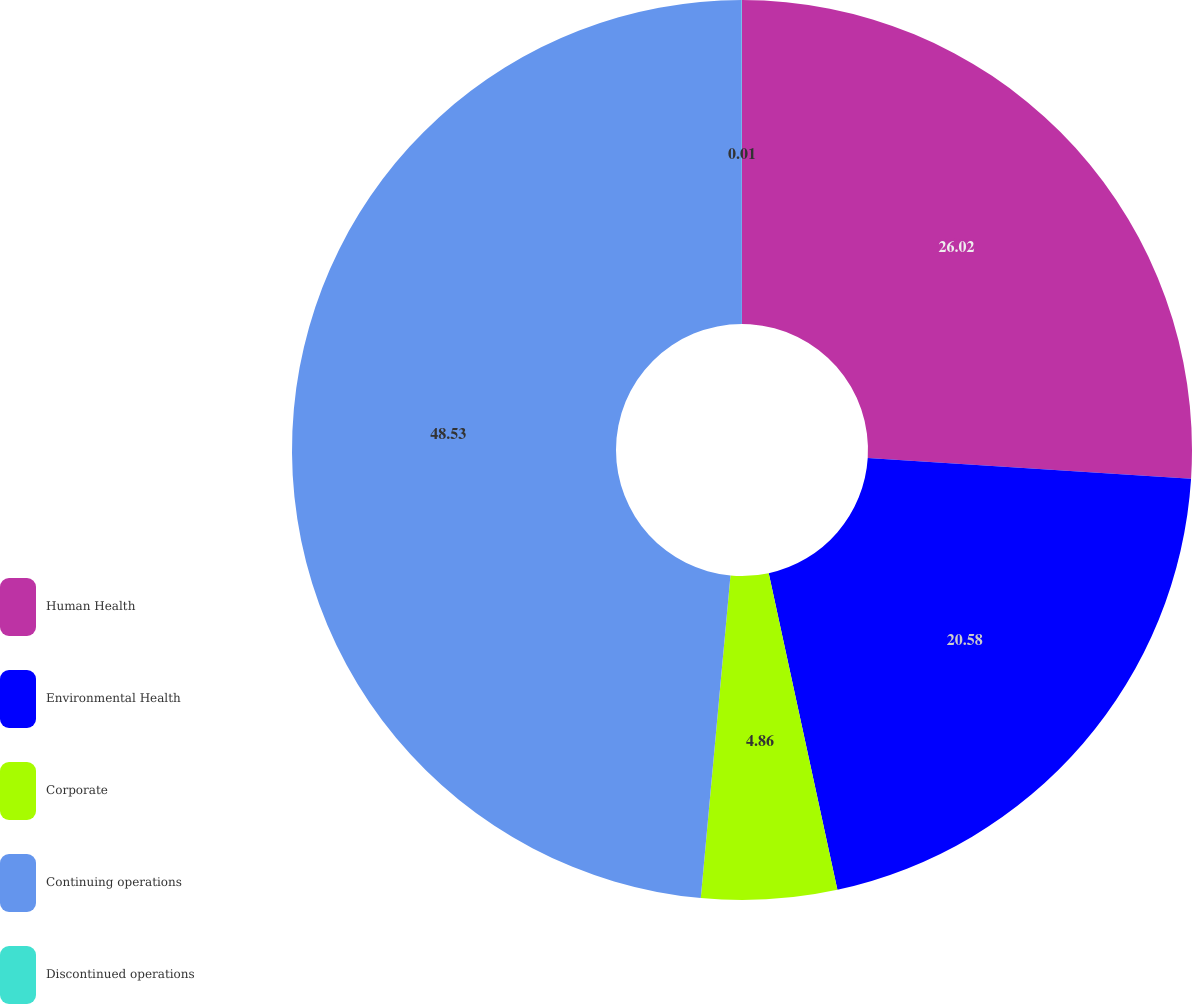<chart> <loc_0><loc_0><loc_500><loc_500><pie_chart><fcel>Human Health<fcel>Environmental Health<fcel>Corporate<fcel>Continuing operations<fcel>Discontinued operations<nl><fcel>26.02%<fcel>20.58%<fcel>4.86%<fcel>48.53%<fcel>0.01%<nl></chart> 